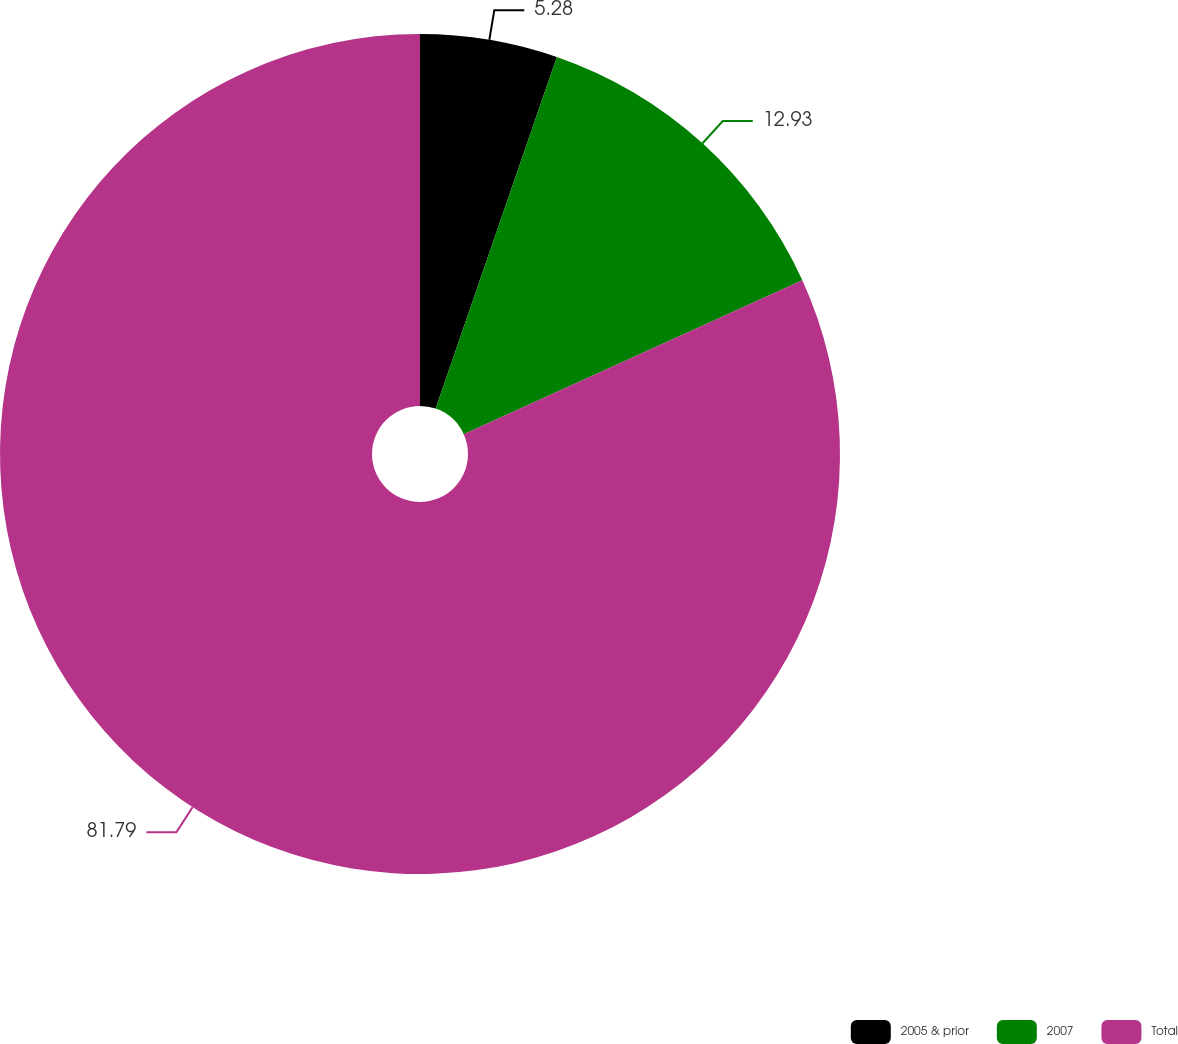Convert chart to OTSL. <chart><loc_0><loc_0><loc_500><loc_500><pie_chart><fcel>2005 & prior<fcel>2007<fcel>Total<nl><fcel>5.28%<fcel>12.93%<fcel>81.79%<nl></chart> 